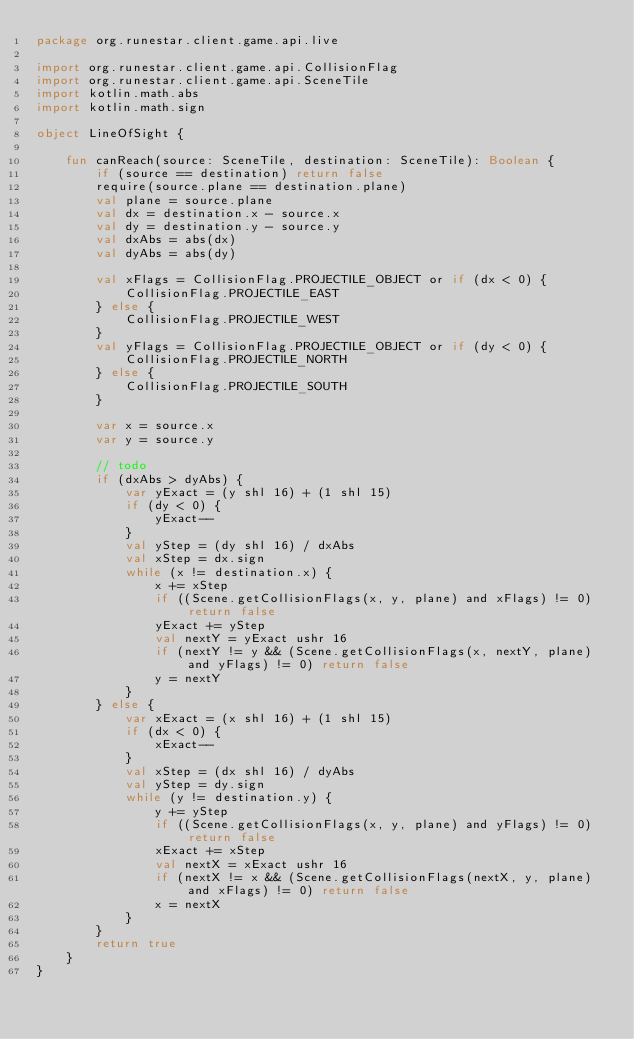Convert code to text. <code><loc_0><loc_0><loc_500><loc_500><_Kotlin_>package org.runestar.client.game.api.live

import org.runestar.client.game.api.CollisionFlag
import org.runestar.client.game.api.SceneTile
import kotlin.math.abs
import kotlin.math.sign

object LineOfSight {

    fun canReach(source: SceneTile, destination: SceneTile): Boolean {
        if (source == destination) return false
        require(source.plane == destination.plane)
        val plane = source.plane
        val dx = destination.x - source.x
        val dy = destination.y - source.y
        val dxAbs = abs(dx)
        val dyAbs = abs(dy)

        val xFlags = CollisionFlag.PROJECTILE_OBJECT or if (dx < 0) {
            CollisionFlag.PROJECTILE_EAST
        } else {
            CollisionFlag.PROJECTILE_WEST
        }
        val yFlags = CollisionFlag.PROJECTILE_OBJECT or if (dy < 0) {
            CollisionFlag.PROJECTILE_NORTH
        } else {
            CollisionFlag.PROJECTILE_SOUTH
        }

        var x = source.x
        var y = source.y

        // todo
        if (dxAbs > dyAbs) {
            var yExact = (y shl 16) + (1 shl 15)
            if (dy < 0) {
                yExact--
            }
            val yStep = (dy shl 16) / dxAbs
            val xStep = dx.sign
            while (x != destination.x) {
                x += xStep
                if ((Scene.getCollisionFlags(x, y, plane) and xFlags) != 0) return false
                yExact += yStep
                val nextY = yExact ushr 16
                if (nextY != y && (Scene.getCollisionFlags(x, nextY, plane) and yFlags) != 0) return false
                y = nextY
            }
        } else {
            var xExact = (x shl 16) + (1 shl 15)
            if (dx < 0) {
                xExact--
            }
            val xStep = (dx shl 16) / dyAbs
            val yStep = dy.sign
            while (y != destination.y) {
                y += yStep
                if ((Scene.getCollisionFlags(x, y, plane) and yFlags) != 0) return false
                xExact += xStep
                val nextX = xExact ushr 16
                if (nextX != x && (Scene.getCollisionFlags(nextX, y, plane) and xFlags) != 0) return false
                x = nextX
            }
        }
        return true
    }
}</code> 